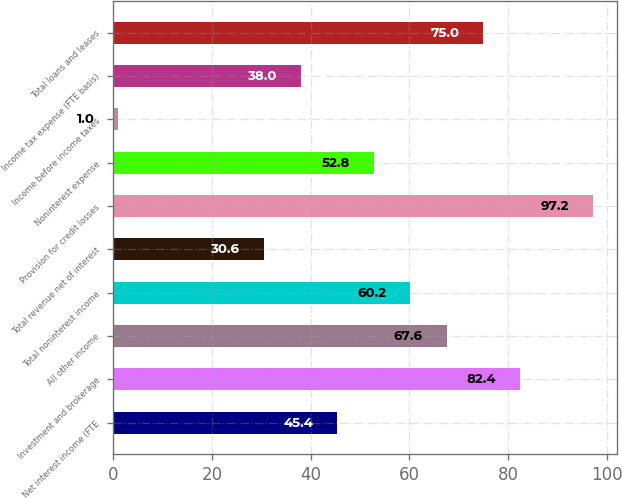<chart> <loc_0><loc_0><loc_500><loc_500><bar_chart><fcel>Net interest income (FTE<fcel>Investment and brokerage<fcel>All other income<fcel>Total noninterest income<fcel>Total revenue net of interest<fcel>Provision for credit losses<fcel>Noninterest expense<fcel>Income before income taxes<fcel>Income tax expense (FTE basis)<fcel>Total loans and leases<nl><fcel>45.4<fcel>82.4<fcel>67.6<fcel>60.2<fcel>30.6<fcel>97.2<fcel>52.8<fcel>1<fcel>38<fcel>75<nl></chart> 